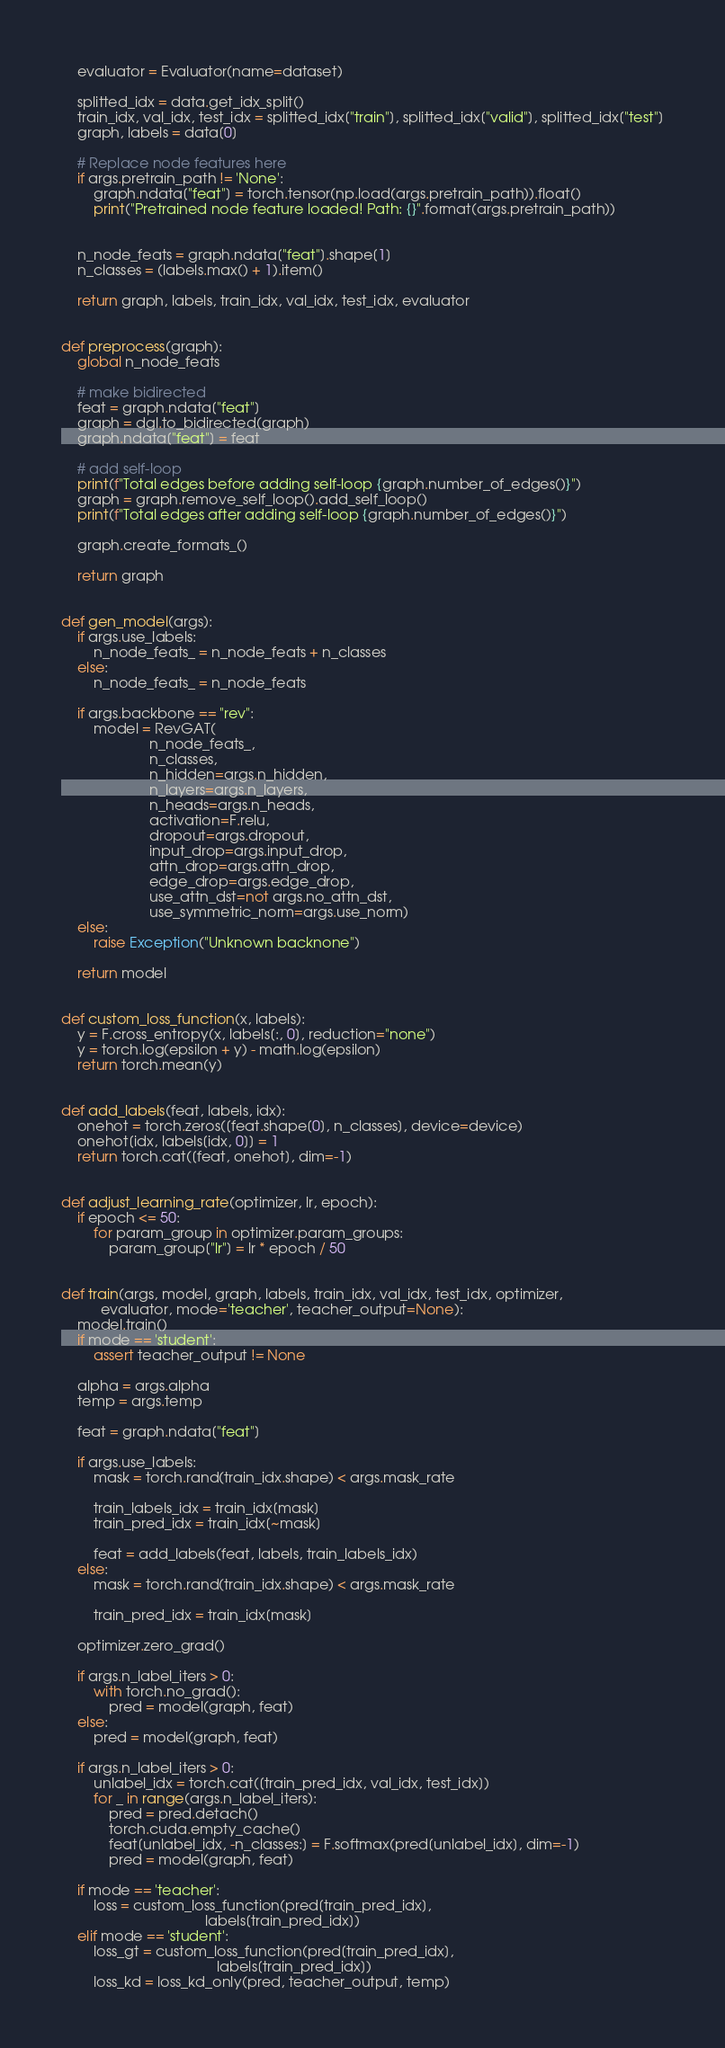<code> <loc_0><loc_0><loc_500><loc_500><_Python_>    evaluator = Evaluator(name=dataset)

    splitted_idx = data.get_idx_split()
    train_idx, val_idx, test_idx = splitted_idx["train"], splitted_idx["valid"], splitted_idx["test"]
    graph, labels = data[0]
    
    # Replace node features here
    if args.pretrain_path != 'None':
        graph.ndata["feat"] = torch.tensor(np.load(args.pretrain_path)).float()
        print("Pretrained node feature loaded! Path: {}".format(args.pretrain_path))
        
    
    n_node_feats = graph.ndata["feat"].shape[1]
    n_classes = (labels.max() + 1).item()

    return graph, labels, train_idx, val_idx, test_idx, evaluator


def preprocess(graph):
    global n_node_feats

    # make bidirected
    feat = graph.ndata["feat"]
    graph = dgl.to_bidirected(graph)
    graph.ndata["feat"] = feat

    # add self-loop
    print(f"Total edges before adding self-loop {graph.number_of_edges()}")
    graph = graph.remove_self_loop().add_self_loop()
    print(f"Total edges after adding self-loop {graph.number_of_edges()}")

    graph.create_formats_()

    return graph


def gen_model(args):
    if args.use_labels:
        n_node_feats_ = n_node_feats + n_classes
    else:
        n_node_feats_ = n_node_feats

    if args.backbone == "rev":
        model = RevGAT(
                      n_node_feats_,
                      n_classes,
                      n_hidden=args.n_hidden,
                      n_layers=args.n_layers,
                      n_heads=args.n_heads,
                      activation=F.relu,
                      dropout=args.dropout,
                      input_drop=args.input_drop,
                      attn_drop=args.attn_drop,
                      edge_drop=args.edge_drop,
                      use_attn_dst=not args.no_attn_dst,
                      use_symmetric_norm=args.use_norm)
    else:
        raise Exception("Unknown backnone")

    return model


def custom_loss_function(x, labels):
    y = F.cross_entropy(x, labels[:, 0], reduction="none")
    y = torch.log(epsilon + y) - math.log(epsilon)
    return torch.mean(y)


def add_labels(feat, labels, idx):
    onehot = torch.zeros([feat.shape[0], n_classes], device=device)
    onehot[idx, labels[idx, 0]] = 1
    return torch.cat([feat, onehot], dim=-1)


def adjust_learning_rate(optimizer, lr, epoch):
    if epoch <= 50:
        for param_group in optimizer.param_groups:
            param_group["lr"] = lr * epoch / 50


def train(args, model, graph, labels, train_idx, val_idx, test_idx, optimizer,
          evaluator, mode='teacher', teacher_output=None):
    model.train()
    if mode == 'student':
        assert teacher_output != None

    alpha = args.alpha
    temp = args.temp

    feat = graph.ndata["feat"]

    if args.use_labels:
        mask = torch.rand(train_idx.shape) < args.mask_rate

        train_labels_idx = train_idx[mask]
        train_pred_idx = train_idx[~mask]

        feat = add_labels(feat, labels, train_labels_idx)
    else:
        mask = torch.rand(train_idx.shape) < args.mask_rate

        train_pred_idx = train_idx[mask]

    optimizer.zero_grad()

    if args.n_label_iters > 0:
        with torch.no_grad():
            pred = model(graph, feat)
    else:
        pred = model(graph, feat)

    if args.n_label_iters > 0:
        unlabel_idx = torch.cat([train_pred_idx, val_idx, test_idx])
        for _ in range(args.n_label_iters):
            pred = pred.detach()
            torch.cuda.empty_cache()
            feat[unlabel_idx, -n_classes:] = F.softmax(pred[unlabel_idx], dim=-1)
            pred = model(graph, feat)

    if mode == 'teacher':
        loss = custom_loss_function(pred[train_pred_idx],
                                    labels[train_pred_idx])
    elif mode == 'student':
        loss_gt = custom_loss_function(pred[train_pred_idx],
                                       labels[train_pred_idx])
        loss_kd = loss_kd_only(pred, teacher_output, temp)</code> 